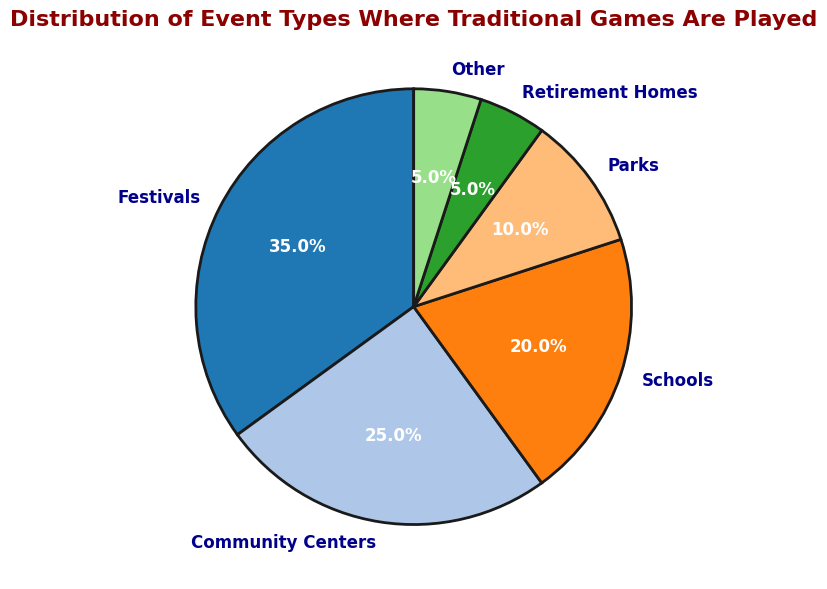What proportion of event types is made up by Festivals and Community Centers combined? To find the proportion, sum the percentages of Festivals (35%) and Community Centers (25%). The combined percentage is 35 + 25 = 60%.
Answer: 60% Which event type has the smallest share? By examining the pie chart, the smallest share in percentage terms belongs to Retirement Homes, which has 5%.
Answer: Retirement Homes Which two event types together account for more than half of the total percentage? From the chart, Festivals (35%) and Community Centers (25%) together account for 35 + 25 = 60%, which is more than half.
Answer: Festivals and Community Centers How does the percentage of Schools compare to that of Parks? According to the figure, Schools have 20%, while Parks have 10%. Hence, the percentage of Schools is double that of Parks.
Answer: Schools have double the percentage of Parks What percentage of events occur in either Parks or Retirement Homes? Adding the percentages for Parks (10%) and Retirement Homes (5%) gives 10 + 5 = 15%.
Answer: 15% Which event types together make up exactly 30% of the distribution? From the chart, Community Centers (25%) and Other (5%) together make exactly 30%. Add the percentages 25 + 5 = 30%.
Answer: Community Centers and Other By how many percentage points does the share of Festivals exceed the share of Schools? The share of Festivals is 35%, and the share of Schools is 20%. Subtracting, 35 - 20 = 15 percentage points.
Answer: 15 percentage points Arrange all event types in descending order based on their percentages. Referencing the pie chart: 1) Festivals (35%), 2) Community Centers (25%), 3) Schools (20%), 4) Parks (10%), 5) Retirement Homes (5%), 6) Other (5%).
Answer: Festivals, Community Centers, Schools, Parks, Retirement Homes, Other What is the combined percentage for the least three common event types? The least three common event types are Parks (10%), Retirement Homes (5%), and Other (5%). Adding these gives 10 + 5 + 5 = 20%.
Answer: 20% What is the visual color used to represent the event type with the largest share? Observing the pie chart, the event type with the largest share is Festivals, which is represented by [mention actual color seen in the chart based on the color palette].
Answer: [Color of Festivals segment] 